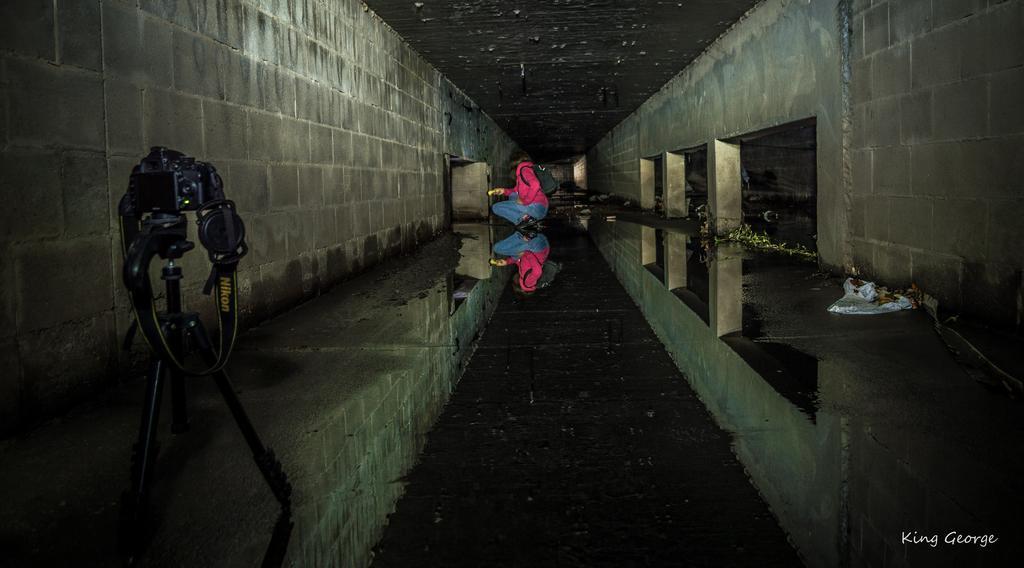How would you summarize this image in a sentence or two? In the picture I can see a camera fixed to the tripod stand is on the left side of the image. Here we can see the stone on the either side of the image and a person wearing pink jacket and carrying a backpack is in the squat position and the background of the image is dark.. 